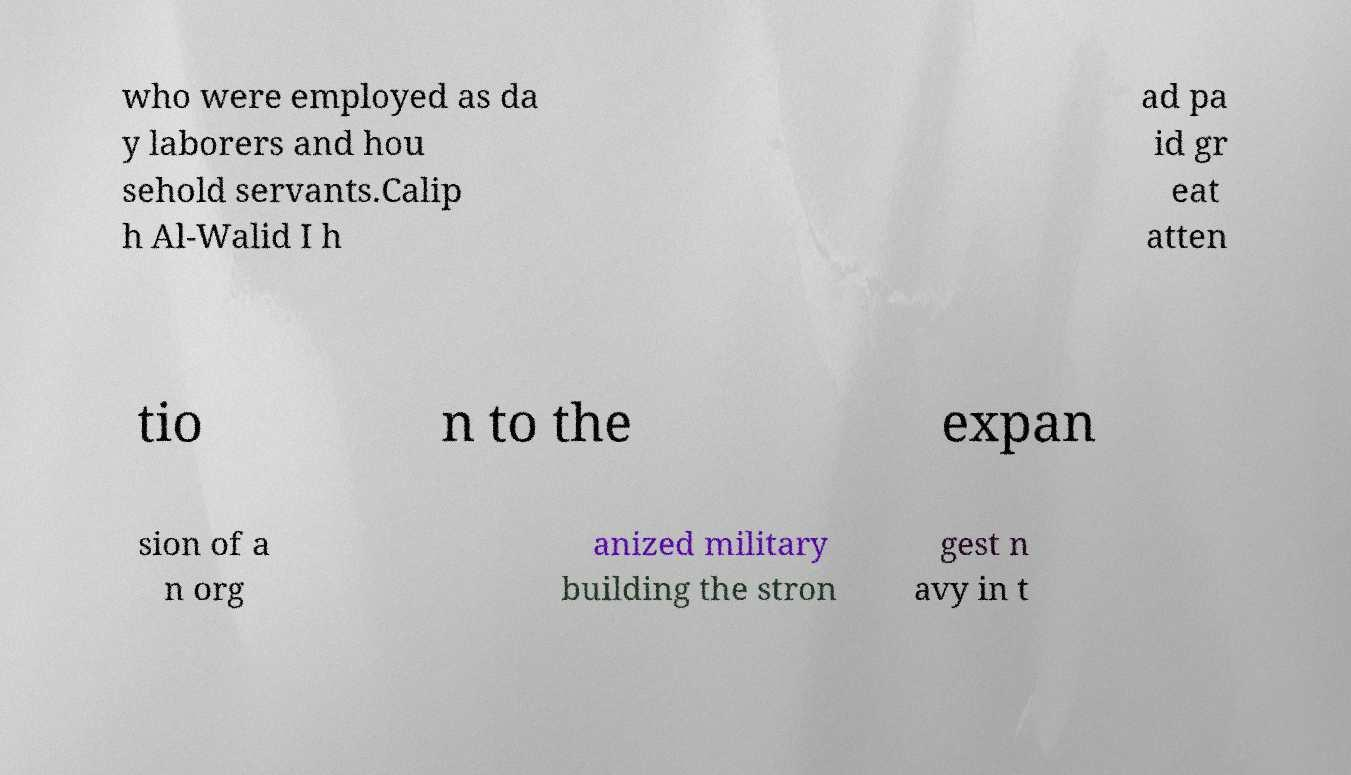What messages or text are displayed in this image? I need them in a readable, typed format. who were employed as da y laborers and hou sehold servants.Calip h Al-Walid I h ad pa id gr eat atten tio n to the expan sion of a n org anized military building the stron gest n avy in t 